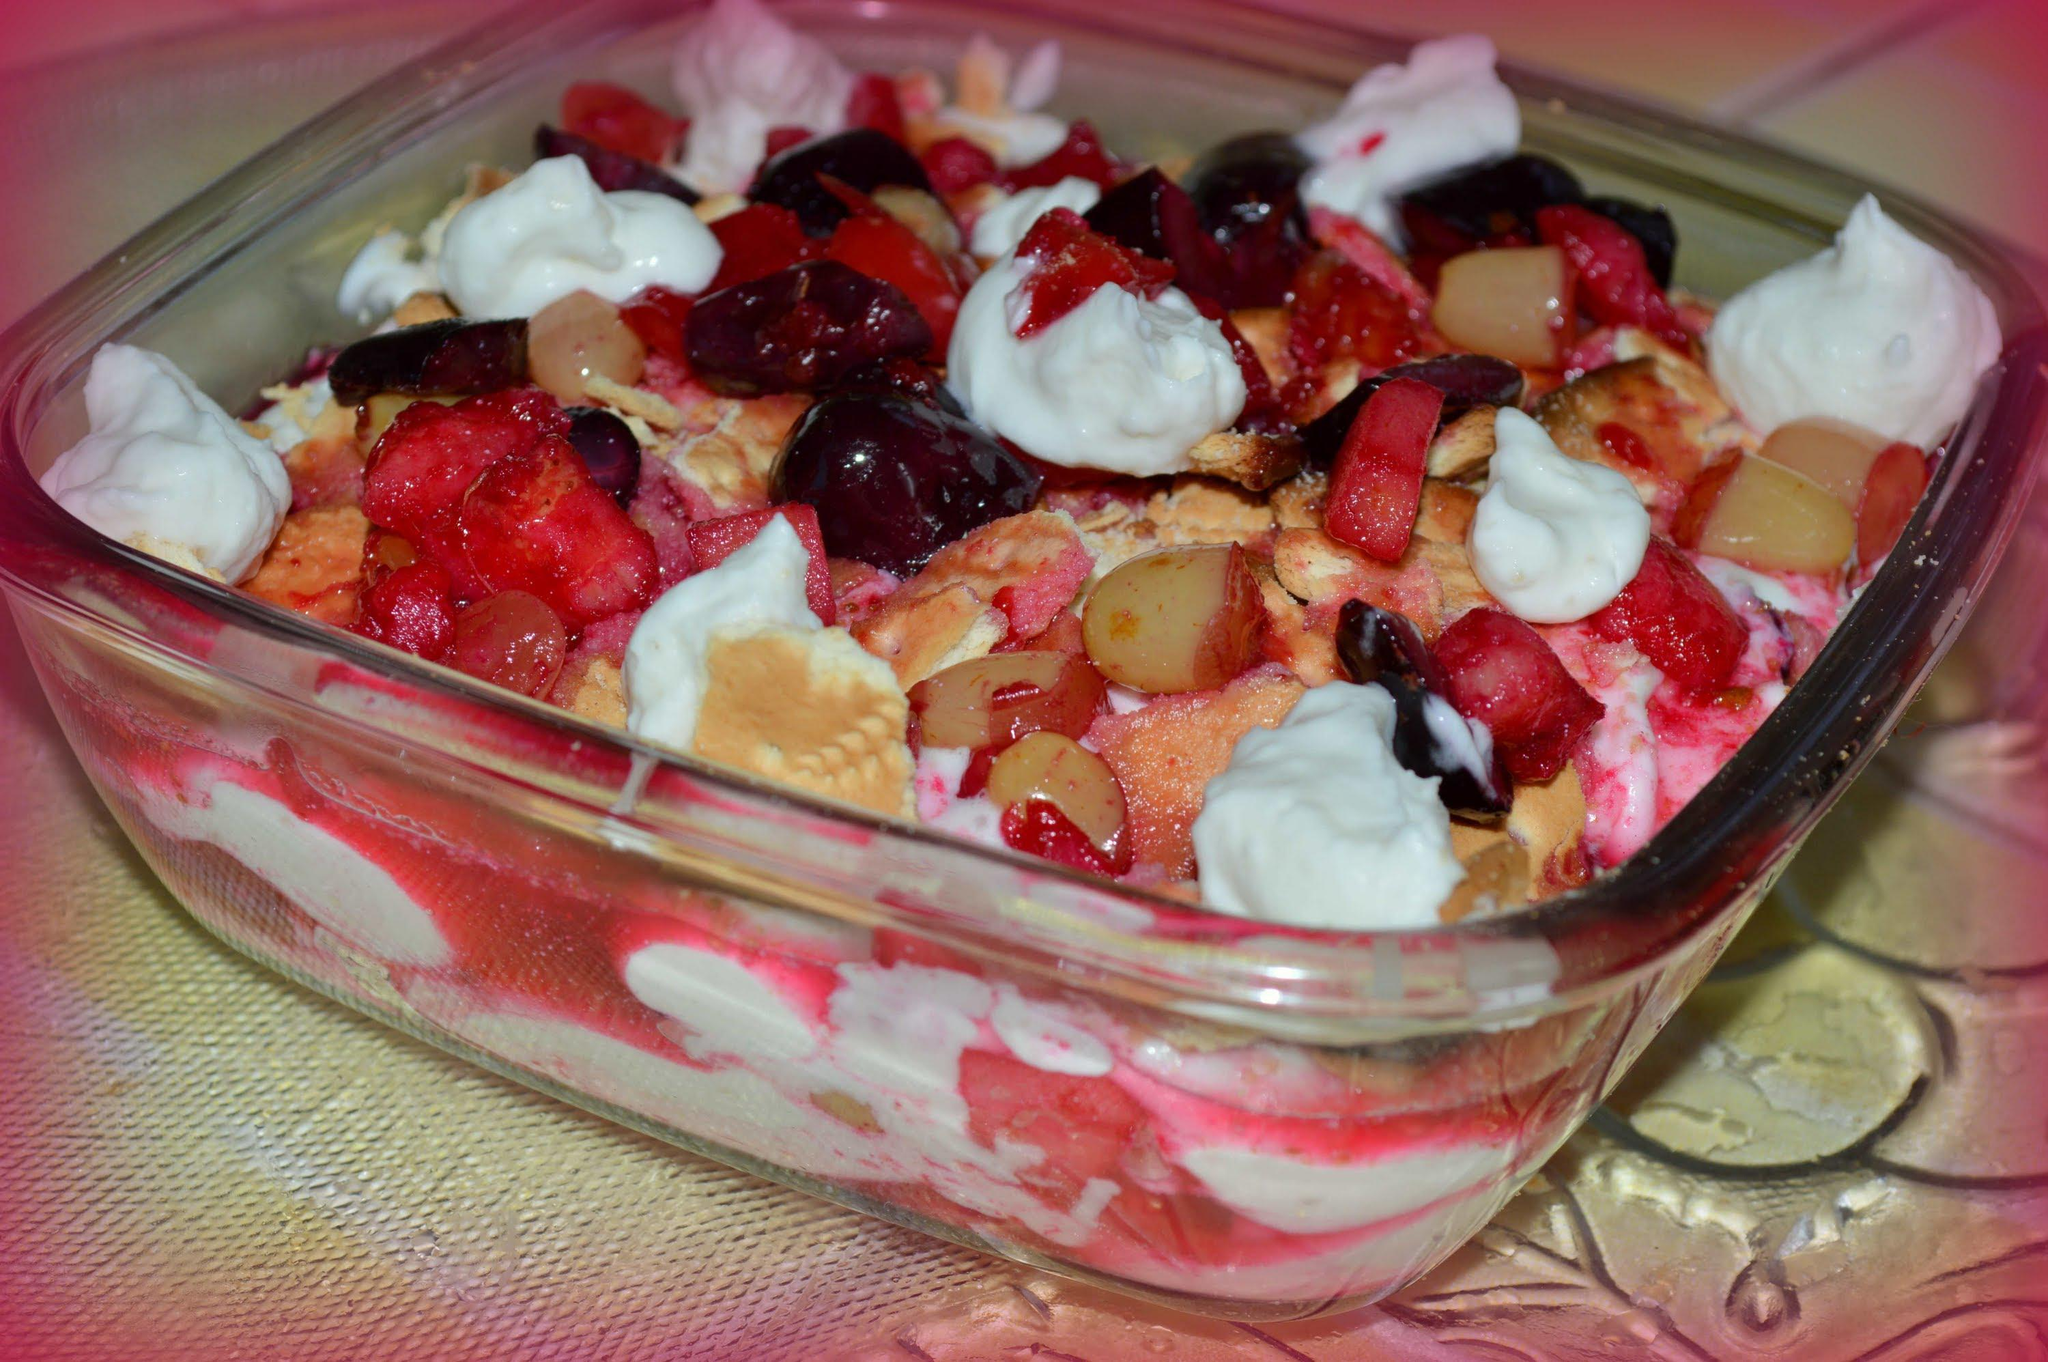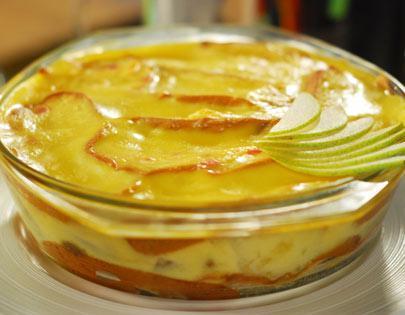The first image is the image on the left, the second image is the image on the right. For the images shown, is this caption "There are spoons near a dessert." true? Answer yes or no. No. The first image is the image on the left, the second image is the image on the right. Analyze the images presented: Is the assertion "There is at least one spoon visible." valid? Answer yes or no. No. 